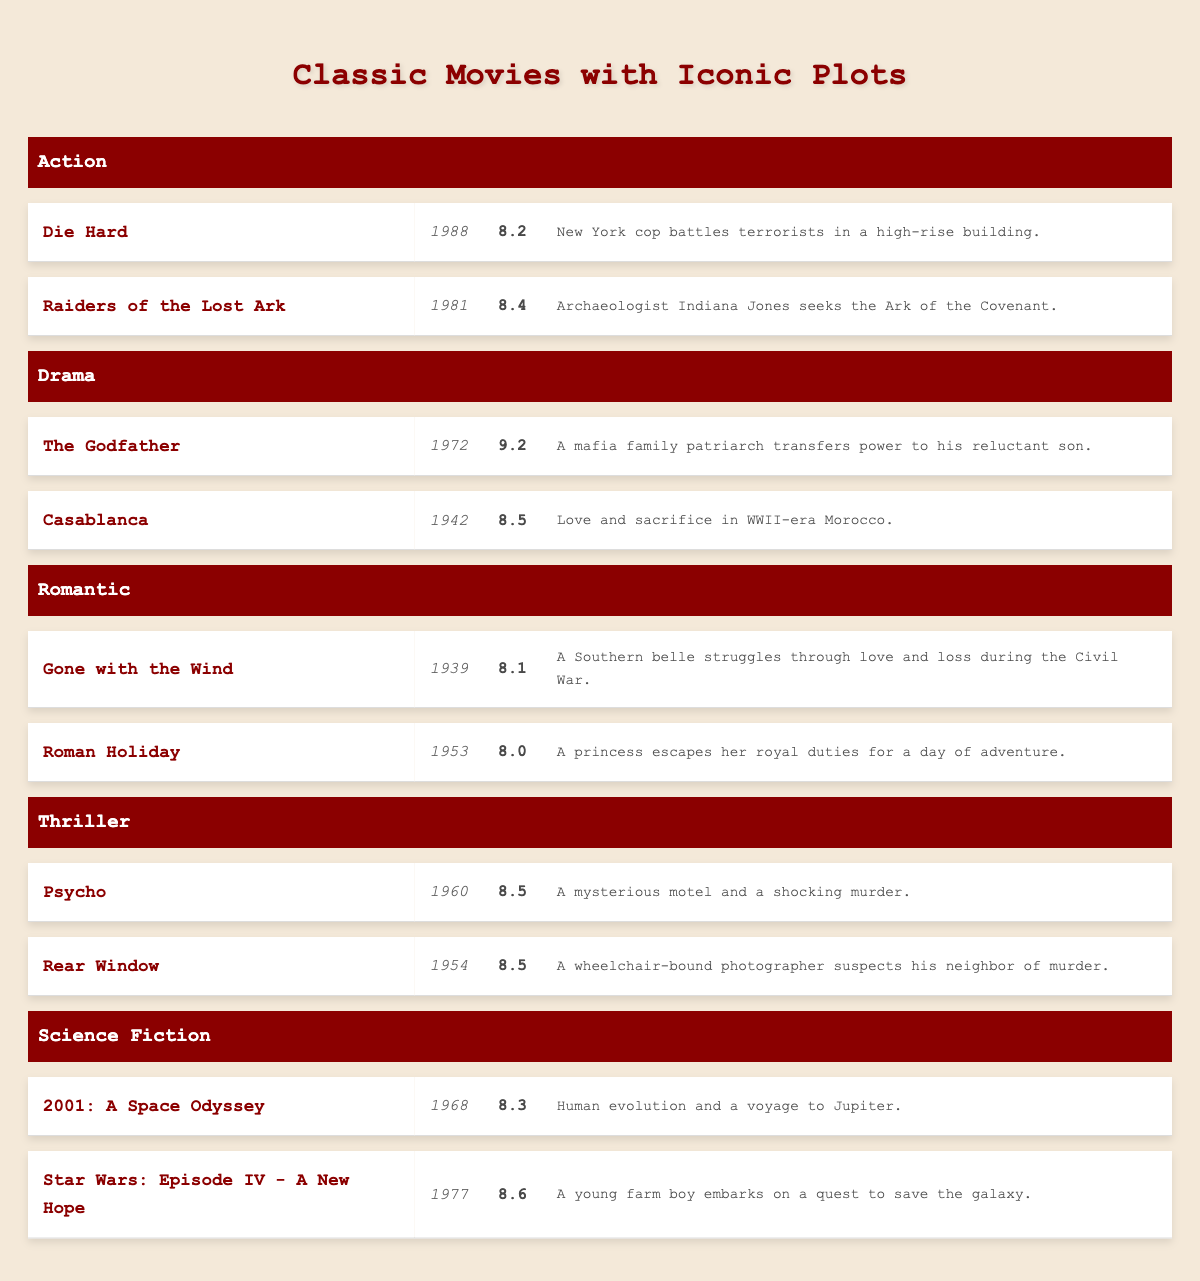What is the viewer rating of "Casablanca"? The table lists "Casablanca" under the Drama genre with a viewer rating of 8.5.
Answer: 8.5 Which movie has the highest viewer rating in the list? The table shows that "The Godfather" has the highest viewer rating of 9.2 under the Drama genre.
Answer: The Godfather Is "Star Wars: Episode IV - A New Hope" rated higher than "Die Hard"? "Star Wars: Episode IV - A New Hope" has a rating of 8.6, while "Die Hard" has a rating of 8.2. Therefore, it is true that "Star Wars: Episode IV - A New Hope" is rated higher.
Answer: Yes What is the average viewer rating of the movies in the Thriller genre? The ratings for the Thriller genre are 8.5 for "Psycho" and 8.5 for "Rear Window". The average rating is calculated as (8.5 + 8.5) / 2 = 8.5.
Answer: 8.5 How many movies in the list are rated above 8? The movies with ratings above 8 are: "Die Hard" (8.2), "Raiders of the Lost Ark" (8.4), "The Godfather" (9.2), "Casablanca" (8.5), "Gone with the Wind" (8.1), "Psycho" (8.5), "Rear Window" (8.5), "2001: A Space Odyssey" (8.3), and "Star Wars: Episode IV - A New Hope" (8.6). That's a total of 9 movies.
Answer: 9 